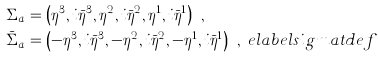<formula> <loc_0><loc_0><loc_500><loc_500>\Sigma _ { a } & = \left ( \eta ^ { 3 } , i \bar { \eta } ^ { 3 } , \eta ^ { 2 } , i \bar { \eta } ^ { 2 } , \eta ^ { 1 } , i \bar { \eta } ^ { 1 } \right ) \ , \\ \bar { \Sigma } _ { a } & = \left ( - \eta ^ { 3 } , i \bar { \eta } ^ { 3 } , - \eta ^ { 2 } , i \bar { \eta } ^ { 2 } , - \eta ^ { 1 } , i \bar { \eta } ^ { 1 } \right ) \ , \ e l a b e l { s i g m a t d e f }</formula> 